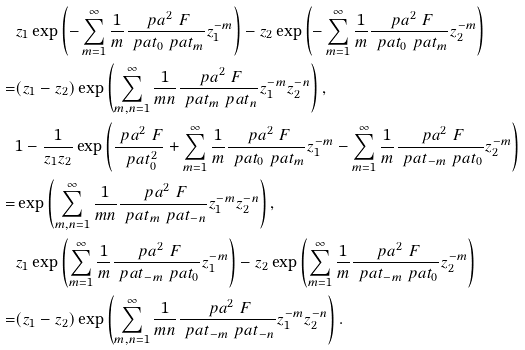Convert formula to latex. <formula><loc_0><loc_0><loc_500><loc_500>& z _ { 1 } \exp \left ( - \sum _ { m = 1 } ^ { \infty } \frac { 1 } { m } \frac { \ p a ^ { 2 } \ F } { \ p a t _ { 0 } \ p a t _ { m } } z _ { 1 } ^ { - m } \right ) - z _ { 2 } \exp \left ( - \sum _ { m = 1 } ^ { \infty } \frac { 1 } { m } \frac { \ p a ^ { 2 } \ F } { \ p a t _ { 0 } \ p a t _ { m } } z _ { 2 } ^ { - m } \right ) \\ = & ( z _ { 1 } - z _ { 2 } ) \exp \left ( \sum _ { m , n = 1 } ^ { \infty } \frac { 1 } { m n } \frac { \ p a ^ { 2 } \ F } { \ p a t _ { m } \ p a t _ { n } } z _ { 1 } ^ { - m } z _ { 2 } ^ { - n } \right ) , \\ & 1 - \frac { 1 } { z _ { 1 } z _ { 2 } } \exp \left ( \frac { \ p a ^ { 2 } \ F } { \ p a t _ { 0 } ^ { 2 } } + \sum _ { m = 1 } ^ { \infty } \frac { 1 } { m } \frac { \ p a ^ { 2 } \ F } { \ p a t _ { 0 } \ p a t _ { m } } z _ { 1 } ^ { - m } - \sum _ { m = 1 } ^ { \infty } \frac { 1 } { m } \frac { \ p a ^ { 2 } \ F } { \ p a t _ { - m } \ p a t _ { 0 } } z _ { 2 } ^ { - m } \right ) \\ = & \exp \left ( \sum _ { m , n = 1 } ^ { \infty } \frac { 1 } { m n } \frac { \ p a ^ { 2 } \ F } { \ p a t _ { m } \ p a t _ { - n } } z _ { 1 } ^ { - m } z _ { 2 } ^ { - n } \right ) , \\ & z _ { 1 } \exp \left ( \sum _ { m = 1 } ^ { \infty } \frac { 1 } { m } \frac { \ p a ^ { 2 } \ F } { \ p a t _ { - m } \ p a t _ { 0 } } z _ { 1 } ^ { - m } \right ) - z _ { 2 } \exp \left ( \sum _ { m = 1 } ^ { \infty } \frac { 1 } { m } \frac { \ p a ^ { 2 } \ F } { \ p a t _ { - m } \ p a t _ { 0 } } z _ { 2 } ^ { - m } \right ) \\ = & ( z _ { 1 } - z _ { 2 } ) \exp \left ( \sum _ { m , n = 1 } ^ { \infty } \frac { 1 } { m n } \frac { \ p a ^ { 2 } \ F } { \ p a t _ { - m } \ p a t _ { - n } } z _ { 1 } ^ { - m } z _ { 2 } ^ { - n } \right ) .</formula> 